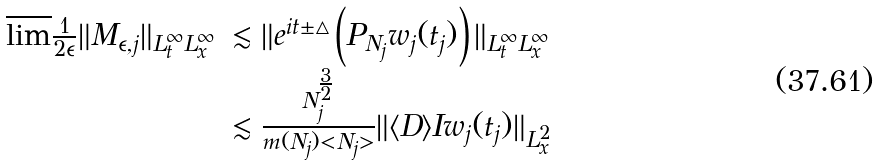<formula> <loc_0><loc_0><loc_500><loc_500>\begin{array} { l l } \overline { \lim } \frac { 1 } { 2 \epsilon } \| M _ { \epsilon , j } \| _ { L _ { t } ^ { \infty } L _ { x } ^ { \infty } } & \lesssim \| e ^ { i t \pm \triangle } \left ( P _ { N _ { j } } w _ { j } ( t _ { j } ) \right ) \| _ { L _ { t } ^ { \infty } L _ { x } ^ { \infty } } \\ & \lesssim \frac { N _ { j } ^ { \frac { 3 } { 2 } } } { m ( N _ { j } ) < N _ { j } > } \| \langle D \rangle I w _ { j } ( t _ { j } ) \| _ { L _ { x } ^ { 2 } } \end{array}</formula> 